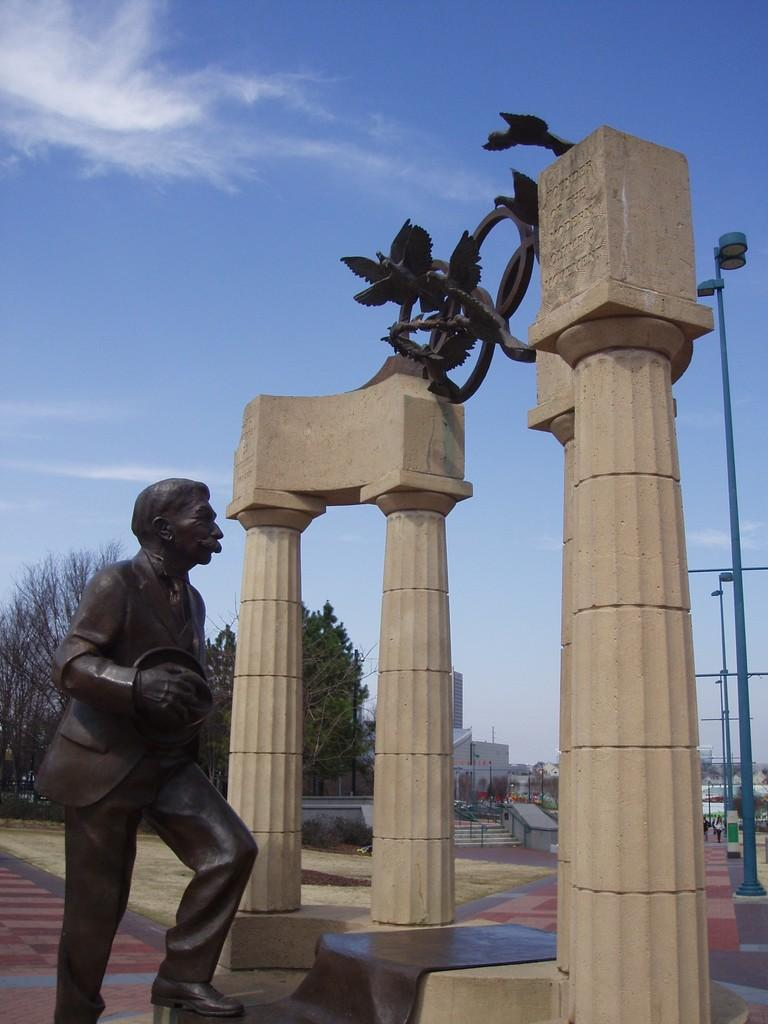What is the main subject of the image? There is a statue of a man in the image. What architectural features are present in the image? There are pillars, poles, and steps in the image. What type of structures can be seen in the image? There are buildings in the image. What natural elements are present in the image? There are trees in the image. What can be seen in the background of the image? The sky with clouds is visible in the background of the image. How many pumpkins are hanging from the poles in the image? There are no pumpkins present in the image; only pillars, poles, and steps are visible. What type of bag is the man carrying in the image? There is no man carrying a bag in the image; the main subject is a statue of a man. 